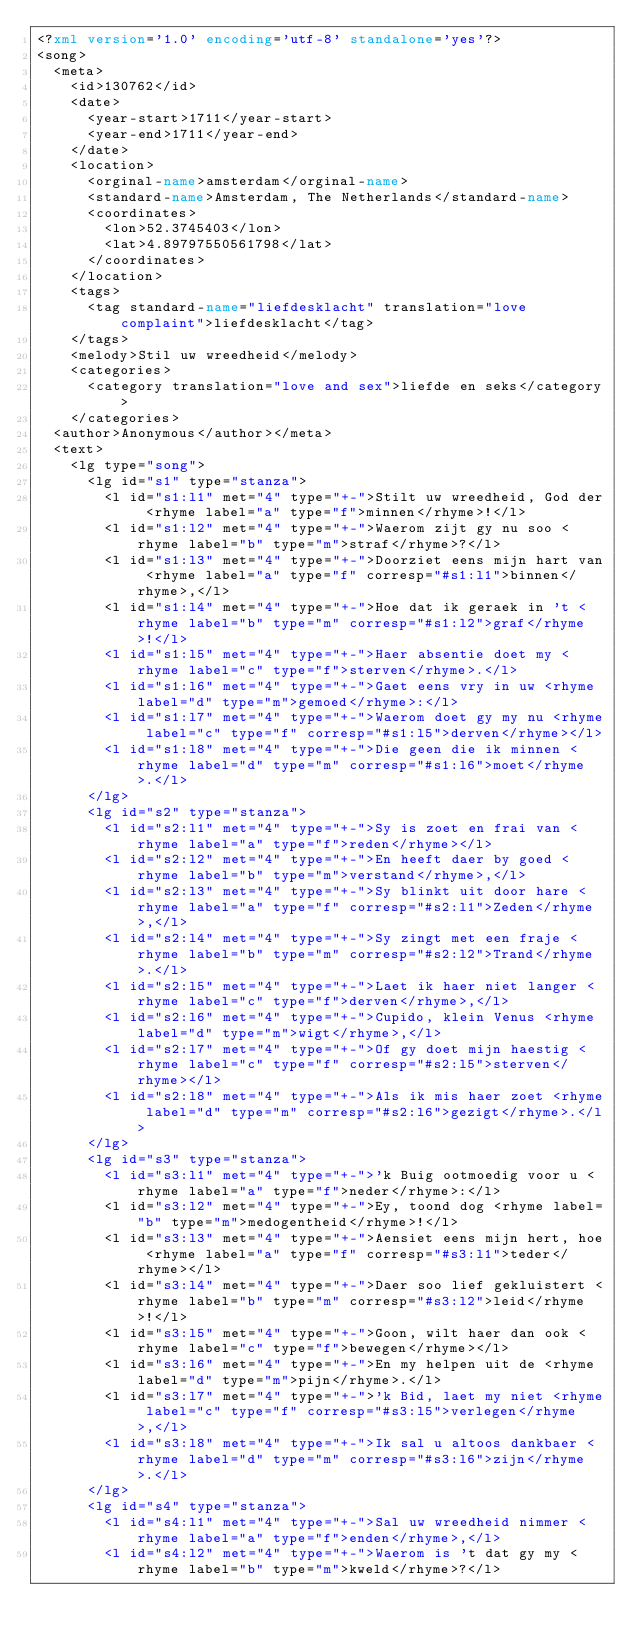Convert code to text. <code><loc_0><loc_0><loc_500><loc_500><_XML_><?xml version='1.0' encoding='utf-8' standalone='yes'?>
<song>
  <meta>
    <id>130762</id>
    <date>
      <year-start>1711</year-start>
      <year-end>1711</year-end>
    </date>
    <location>
      <orginal-name>amsterdam</orginal-name>
      <standard-name>Amsterdam, The Netherlands</standard-name>
      <coordinates>
        <lon>52.3745403</lon>
        <lat>4.89797550561798</lat>
      </coordinates>
    </location>
    <tags>
      <tag standard-name="liefdesklacht" translation="love complaint">liefdesklacht</tag>
    </tags>
    <melody>Stil uw wreedheid</melody>
    <categories>
      <category translation="love and sex">liefde en seks</category>
    </categories>
  <author>Anonymous</author></meta>
  <text>
    <lg type="song">
      <lg id="s1" type="stanza">
        <l id="s1:l1" met="4" type="+-">Stilt uw wreedheid, God der <rhyme label="a" type="f">minnen</rhyme>!</l>
        <l id="s1:l2" met="4" type="+-">Waerom zijt gy nu soo <rhyme label="b" type="m">straf</rhyme>?</l>
        <l id="s1:l3" met="4" type="+-">Doorziet eens mijn hart van <rhyme label="a" type="f" corresp="#s1:l1">binnen</rhyme>,</l>
        <l id="s1:l4" met="4" type="+-">Hoe dat ik geraek in 't <rhyme label="b" type="m" corresp="#s1:l2">graf</rhyme>!</l>
        <l id="s1:l5" met="4" type="+-">Haer absentie doet my <rhyme label="c" type="f">sterven</rhyme>.</l>
        <l id="s1:l6" met="4" type="+-">Gaet eens vry in uw <rhyme label="d" type="m">gemoed</rhyme>:</l>
        <l id="s1:l7" met="4" type="+-">Waerom doet gy my nu <rhyme label="c" type="f" corresp="#s1:l5">derven</rhyme></l>
        <l id="s1:l8" met="4" type="+-">Die geen die ik minnen <rhyme label="d" type="m" corresp="#s1:l6">moet</rhyme>.</l>
      </lg>
      <lg id="s2" type="stanza">
        <l id="s2:l1" met="4" type="+-">Sy is zoet en frai van <rhyme label="a" type="f">reden</rhyme></l>
        <l id="s2:l2" met="4" type="+-">En heeft daer by goed <rhyme label="b" type="m">verstand</rhyme>,</l>
        <l id="s2:l3" met="4" type="+-">Sy blinkt uit door hare <rhyme label="a" type="f" corresp="#s2:l1">Zeden</rhyme>,</l>
        <l id="s2:l4" met="4" type="+-">Sy zingt met een fraje <rhyme label="b" type="m" corresp="#s2:l2">Trand</rhyme>.</l>
        <l id="s2:l5" met="4" type="+-">Laet ik haer niet langer <rhyme label="c" type="f">derven</rhyme>,</l>
        <l id="s2:l6" met="4" type="+-">Cupido, klein Venus <rhyme label="d" type="m">wigt</rhyme>,</l>
        <l id="s2:l7" met="4" type="+-">Of gy doet mijn haestig <rhyme label="c" type="f" corresp="#s2:l5">sterven</rhyme></l>
        <l id="s2:l8" met="4" type="+-">Als ik mis haer zoet <rhyme label="d" type="m" corresp="#s2:l6">gezigt</rhyme>.</l>
      </lg>
      <lg id="s3" type="stanza">
        <l id="s3:l1" met="4" type="+-">'k Buig ootmoedig voor u <rhyme label="a" type="f">neder</rhyme>:</l>
        <l id="s3:l2" met="4" type="+-">Ey, toond dog <rhyme label="b" type="m">medogentheid</rhyme>!</l>
        <l id="s3:l3" met="4" type="+-">Aensiet eens mijn hert, hoe <rhyme label="a" type="f" corresp="#s3:l1">teder</rhyme></l>
        <l id="s3:l4" met="4" type="+-">Daer soo lief gekluistert <rhyme label="b" type="m" corresp="#s3:l2">leid</rhyme>!</l>
        <l id="s3:l5" met="4" type="+-">Goon, wilt haer dan ook <rhyme label="c" type="f">bewegen</rhyme></l>
        <l id="s3:l6" met="4" type="+-">En my helpen uit de <rhyme label="d" type="m">pijn</rhyme>.</l>
        <l id="s3:l7" met="4" type="+-">'k Bid, laet my niet <rhyme label="c" type="f" corresp="#s3:l5">verlegen</rhyme>,</l>
        <l id="s3:l8" met="4" type="+-">Ik sal u altoos dankbaer <rhyme label="d" type="m" corresp="#s3:l6">zijn</rhyme>.</l>
      </lg>
      <lg id="s4" type="stanza">
        <l id="s4:l1" met="4" type="+-">Sal uw wreedheid nimmer <rhyme label="a" type="f">enden</rhyme>,</l>
        <l id="s4:l2" met="4" type="+-">Waerom is 't dat gy my <rhyme label="b" type="m">kweld</rhyme>?</l></code> 